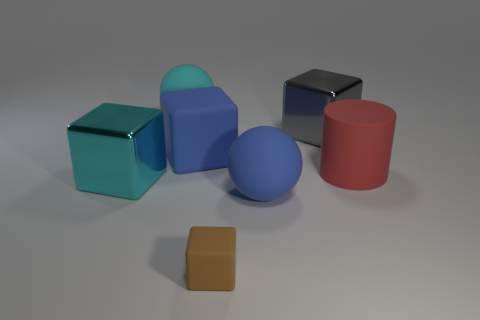Add 3 brown matte blocks. How many objects exist? 10 Subtract all large rubber cubes. How many cubes are left? 3 Subtract all brown blocks. How many blocks are left? 3 Subtract 2 cubes. How many cubes are left? 2 Subtract all spheres. How many objects are left? 5 Add 4 rubber blocks. How many rubber blocks exist? 6 Subtract 0 red blocks. How many objects are left? 7 Subtract all cyan balls. Subtract all green cylinders. How many balls are left? 1 Subtract all big cyan spheres. Subtract all big cyan matte balls. How many objects are left? 5 Add 3 cyan spheres. How many cyan spheres are left? 4 